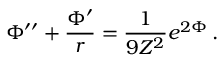<formula> <loc_0><loc_0><loc_500><loc_500>\Phi ^ { \prime \prime } + \frac { \Phi ^ { \prime } } { r } = \frac { 1 } { 9 Z ^ { 2 } } e ^ { 2 \Phi } \, .</formula> 